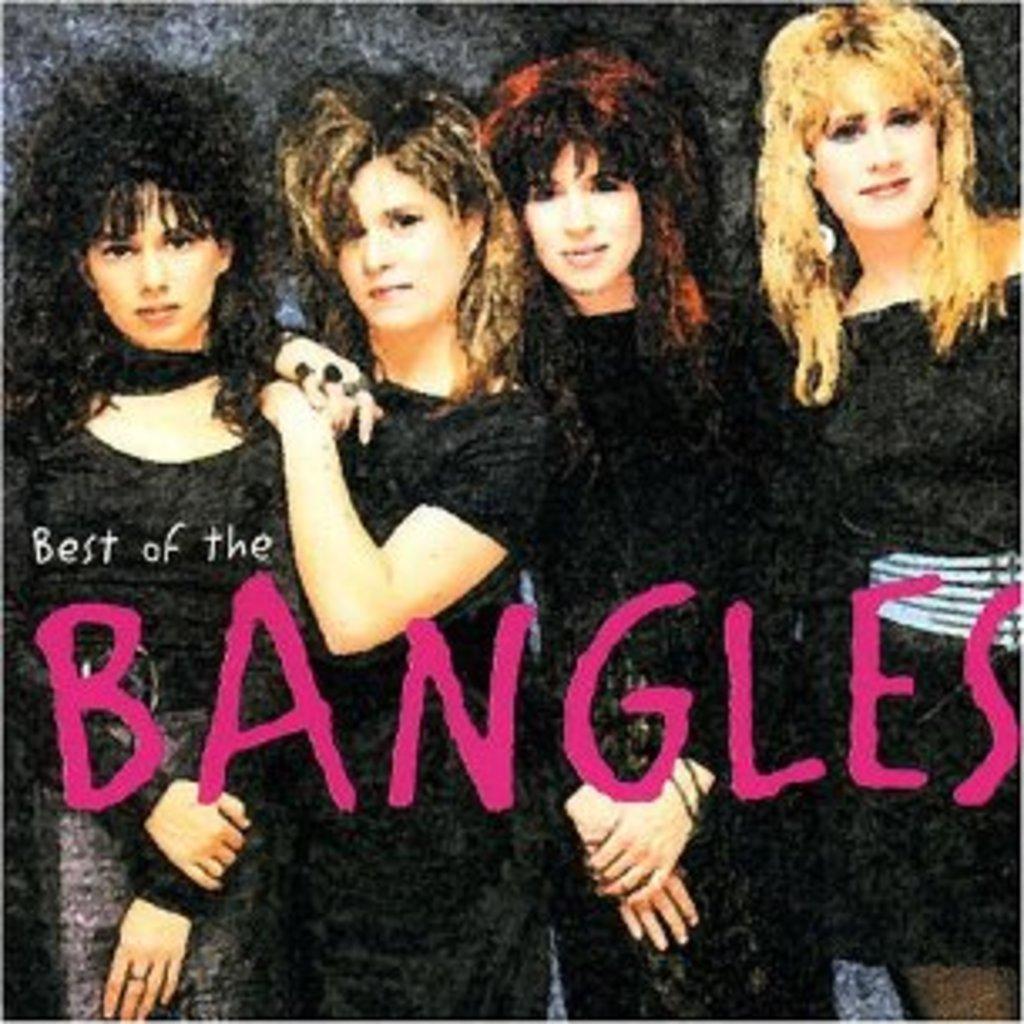Please provide a concise description of this image. In this image we can see a poster in which some text is written on it. And we can see 4 ladies are seen in the different postures. And we can see the different hairstyles black, curly, wavy, whitey. 